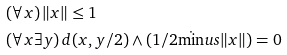Convert formula to latex. <formula><loc_0><loc_0><loc_500><loc_500>& ( \forall x ) \, \| x \| \leq 1 \\ & ( \forall x \exists y ) \, d ( x , y / 2 ) \land ( 1 / 2 \dot { \min } u s \| x \| ) = 0</formula> 